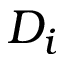Convert formula to latex. <formula><loc_0><loc_0><loc_500><loc_500>D _ { i }</formula> 